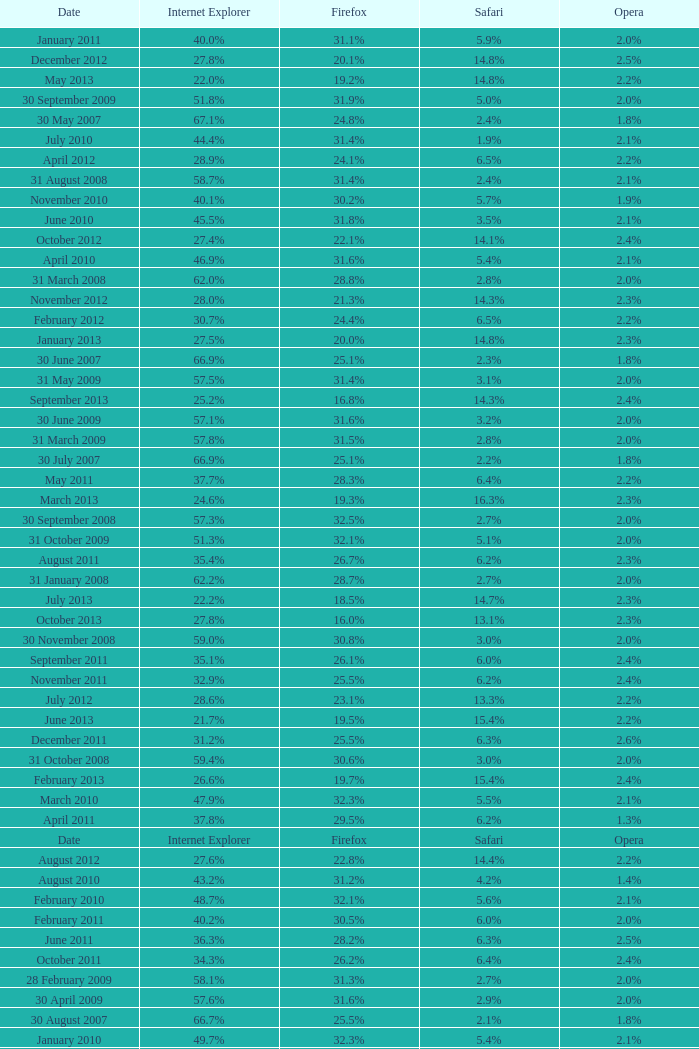What is the safari value with a 28.0% internet explorer? 14.3%. Could you parse the entire table as a dict? {'header': ['Date', 'Internet Explorer', 'Firefox', 'Safari', 'Opera'], 'rows': [['January 2011', '40.0%', '31.1%', '5.9%', '2.0%'], ['December 2012', '27.8%', '20.1%', '14.8%', '2.5%'], ['May 2013', '22.0%', '19.2%', '14.8%', '2.2%'], ['30 September 2009', '51.8%', '31.9%', '5.0%', '2.0%'], ['30 May 2007', '67.1%', '24.8%', '2.4%', '1.8%'], ['July 2010', '44.4%', '31.4%', '1.9%', '2.1%'], ['April 2012', '28.9%', '24.1%', '6.5%', '2.2%'], ['31 August 2008', '58.7%', '31.4%', '2.4%', '2.1%'], ['November 2010', '40.1%', '30.2%', '5.7%', '1.9%'], ['June 2010', '45.5%', '31.8%', '3.5%', '2.1%'], ['October 2012', '27.4%', '22.1%', '14.1%', '2.4%'], ['April 2010', '46.9%', '31.6%', '5.4%', '2.1%'], ['31 March 2008', '62.0%', '28.8%', '2.8%', '2.0%'], ['November 2012', '28.0%', '21.3%', '14.3%', '2.3%'], ['February 2012', '30.7%', '24.4%', '6.5%', '2.2%'], ['January 2013', '27.5%', '20.0%', '14.8%', '2.3%'], ['30 June 2007', '66.9%', '25.1%', '2.3%', '1.8%'], ['31 May 2009', '57.5%', '31.4%', '3.1%', '2.0%'], ['September 2013', '25.2%', '16.8%', '14.3%', '2.4%'], ['30 June 2009', '57.1%', '31.6%', '3.2%', '2.0%'], ['31 March 2009', '57.8%', '31.5%', '2.8%', '2.0%'], ['30 July 2007', '66.9%', '25.1%', '2.2%', '1.8%'], ['May 2011', '37.7%', '28.3%', '6.4%', '2.2%'], ['March 2013', '24.6%', '19.3%', '16.3%', '2.3%'], ['30 September 2008', '57.3%', '32.5%', '2.7%', '2.0%'], ['31 October 2009', '51.3%', '32.1%', '5.1%', '2.0%'], ['August 2011', '35.4%', '26.7%', '6.2%', '2.3%'], ['31 January 2008', '62.2%', '28.7%', '2.7%', '2.0%'], ['July 2013', '22.2%', '18.5%', '14.7%', '2.3%'], ['October 2013', '27.8%', '16.0%', '13.1%', '2.3%'], ['30 November 2008', '59.0%', '30.8%', '3.0%', '2.0%'], ['September 2011', '35.1%', '26.1%', '6.0%', '2.4%'], ['November 2011', '32.9%', '25.5%', '6.2%', '2.4%'], ['July 2012', '28.6%', '23.1%', '13.3%', '2.2%'], ['June 2013', '21.7%', '19.5%', '15.4%', '2.2%'], ['December 2011', '31.2%', '25.5%', '6.3%', '2.6%'], ['31 October 2008', '59.4%', '30.6%', '3.0%', '2.0%'], ['February 2013', '26.6%', '19.7%', '15.4%', '2.4%'], ['March 2010', '47.9%', '32.3%', '5.5%', '2.1%'], ['April 2011', '37.8%', '29.5%', '6.2%', '1.3%'], ['Date', 'Internet Explorer', 'Firefox', 'Safari', 'Opera'], ['August 2012', '27.6%', '22.8%', '14.4%', '2.2%'], ['August 2010', '43.2%', '31.2%', '4.2%', '1.4%'], ['February 2010', '48.7%', '32.1%', '5.6%', '2.1%'], ['February 2011', '40.2%', '30.5%', '6.0%', '2.0%'], ['June 2011', '36.3%', '28.2%', '6.3%', '2.5%'], ['October 2011', '34.3%', '26.2%', '6.4%', '2.4%'], ['28 February 2009', '58.1%', '31.3%', '2.7%', '2.0%'], ['30 April 2009', '57.6%', '31.6%', '2.9%', '2.0%'], ['30 August 2007', '66.7%', '25.5%', '2.1%', '1.8%'], ['January 2010', '49.7%', '32.3%', '5.4%', '2.1%'], ['April 2013', '23.1%', '20.7%', '15.1%', '2.3%'], ['31 December 2008', '58.6%', '31.1%', '2.9%', '2.1%'], ['30 June 2008', '61.7%', '29.1%', '2.5%', '2.0%'], ['May 2012', '28.8%', '23.3%', '6.2%', '2.3%'], ['August 2013', '24.0%', '17.8%', '14.2%', '2.4%'], ['31 May 2008', '61.9%', '28.9%', '2.7%', '2.0%'], ['31 July 2009', '53.1%', '31.7%', '4.6%', '1.8%'], ['May 2010', '45.7%', '32.2%', '5.3%', '2.0%'], ['30 November 2009', '51.2%', '32.0%', '5.2%', '1.2%'], ['September 2012', '27.6%', '22.8%', '14.1%', '2.3%'], ['June 2012', '29.9%', '23.1%', '6.5%', '2.4%'], ['31 July 2008', '60.9%', '29.7%', '2.4%', '2.0%'], ['30 October 2007', '65.5%', '26.3%', '2.3%', '1.8%'], ['January 2012', '30.9%', '24.8%', '6.5%', '2.5%'], ['September 2010', '43.3%', '30.4%', '5.5%', '1.6%'], ['March 2011', '39.3%', '30.1%', '6.0%', '2.0%'], ['10 November 2007', '63.0%', '27.8%', '2.5%', '2.0%'], ['20 September 2007', '66.6%', '25.6%', '2.1%', '1.8%'], ['1 December 2007', '62.8%', '28.0%', '2.6%', '2.0%'], ['31 January 2009', '58.4%', '31.1%', '2.7%', '2.0%'], ['October 2010', '41.6%', '29.9%', '5.5%', '1.9%'], ['March 2012', '30.0%', '24.3%', '6.4%', '2.1%'], ['31 December 2009', '50.3%', '32.3%', '5.1%', '2.1%'], ['30 April 2008', '62.0%', '28.8%', '2.8%', '2.0%'], ['29 February 2008', '62.0%', '28.7%', '2.8%', '2.0%'], ['July 2011', '35.6%', '27.7%', '6.4%', '2.3%'], ['December 2010', '41.3%', '30.3%', '5.9%', '2.0%'], ['31 August 2009', '52.4%', '32.1%', '4.9%', '1.9%']]} 